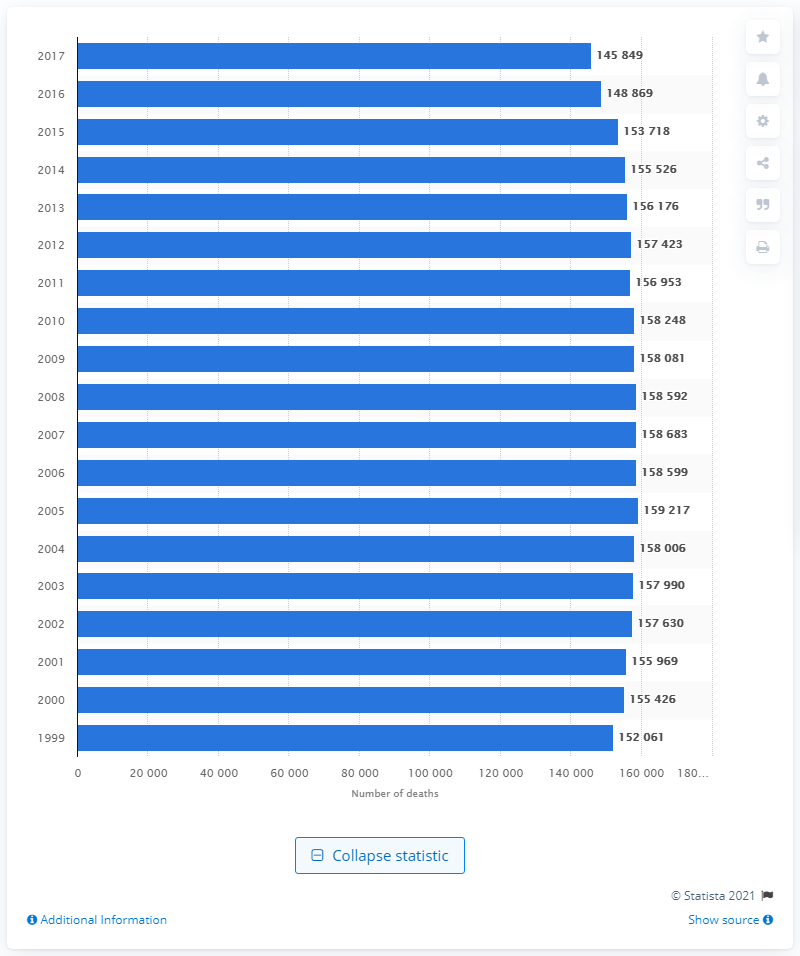In what year was the highest number of deaths due to lung and bronchus cancer reported? According to the image provided, the year with the highest number of deaths due to lung and bronchus cancer was 2005, with a total of 159,217 reported deaths. It is important to recognize trends like these to inform public health policies and focus research efforts on effective treatment and prevention strategies. 